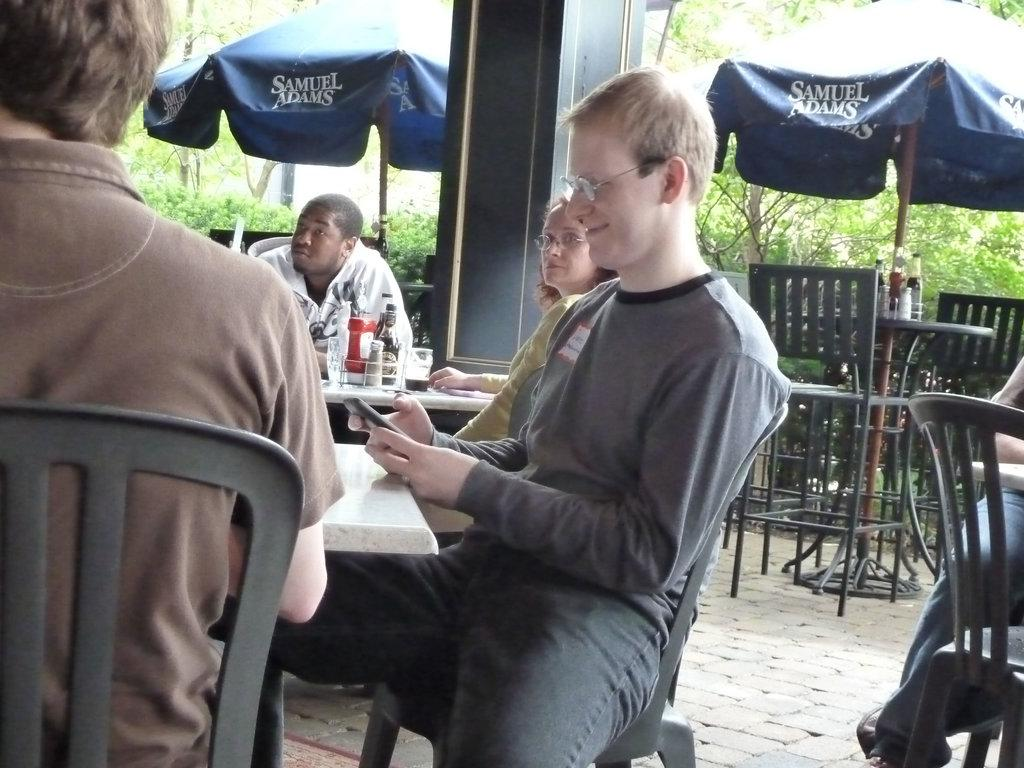How many people are present in the image? There are four people in the image. What are the people doing in the image? The people are sitting at a table. What can be seen on the table besides the people? There are food items on the table. What is visible in the background of the image? There is a Samuel Adams tent in the background of the image. How much sugar is in the basin on the table? There is no basin or sugar present on the table in the image. What type of cord is used to hold the tent in the background? The image does not show any cords or details about the tent's structure, so it cannot be determined from the image. 